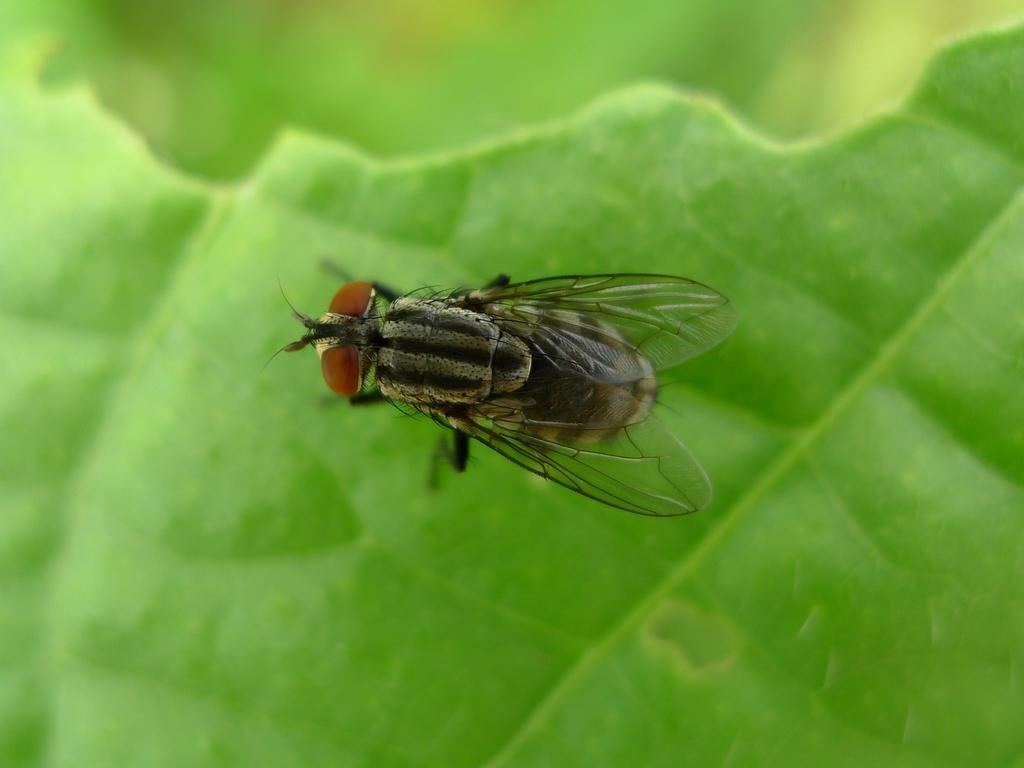In one or two sentences, can you explain what this image depicts? This image consists of a house fly on a green leaf. 